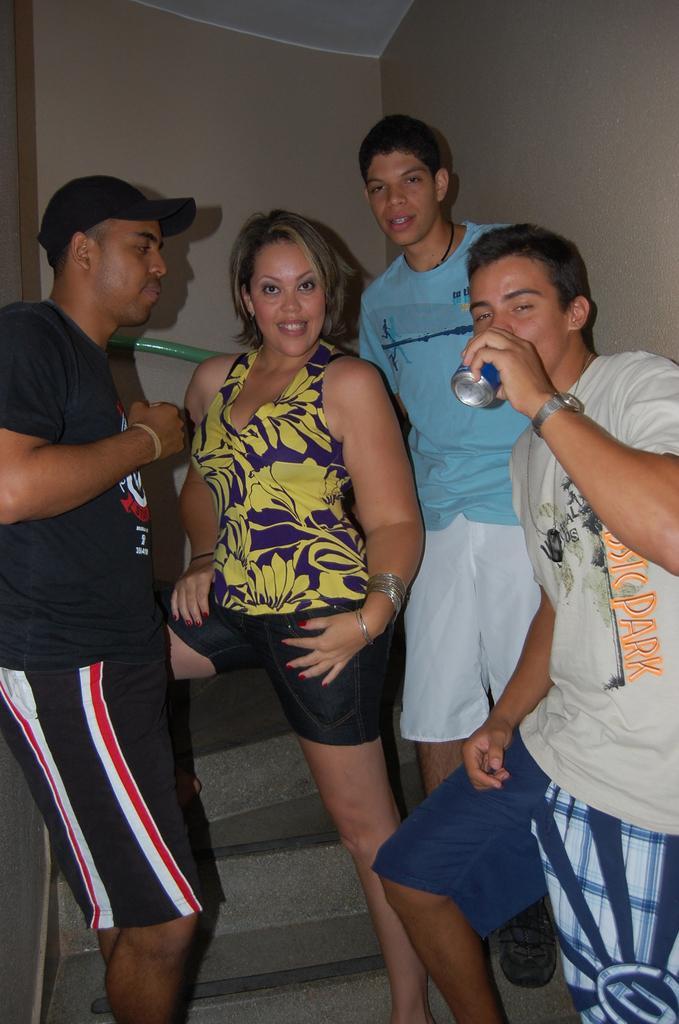Describe this image in one or two sentences. In the picture we can see three men and one woman standing on the steps and one man is drinking something with a tin holding it and one man is wearing a cap which is black in color and behind them we can see a wall. 